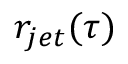Convert formula to latex. <formula><loc_0><loc_0><loc_500><loc_500>r _ { j e t } ( \tau )</formula> 